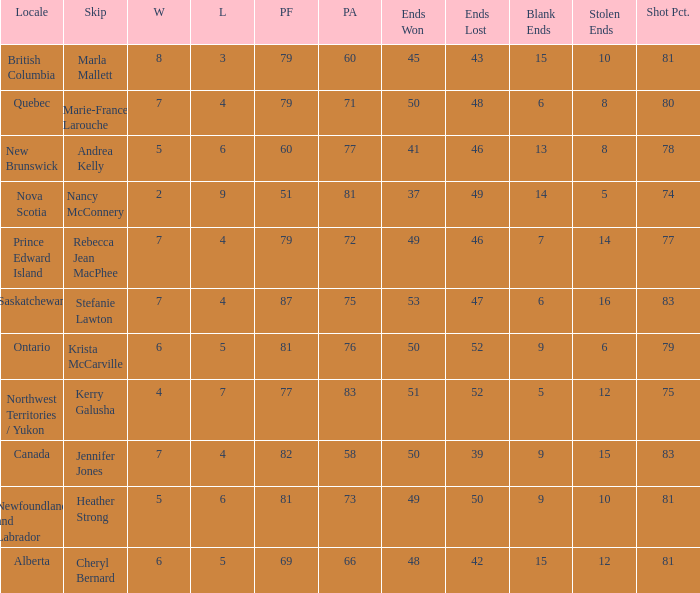Where was the shot pct 78? New Brunswick. 